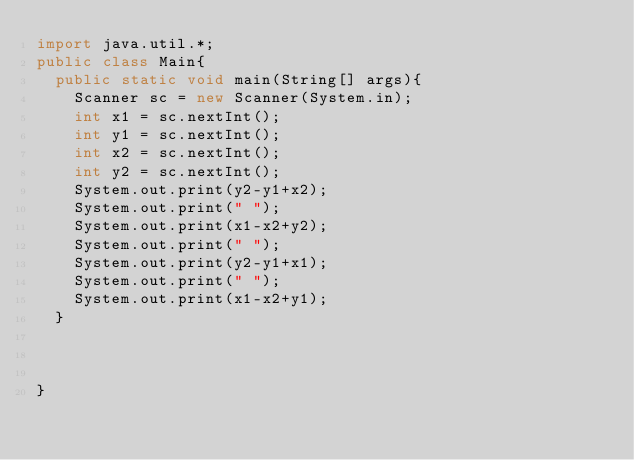Convert code to text. <code><loc_0><loc_0><loc_500><loc_500><_Java_>import java.util.*;
public class Main{
  public static void main(String[] args){
    Scanner sc = new Scanner(System.in);
    int x1 = sc.nextInt();
    int y1 = sc.nextInt();
    int x2 = sc.nextInt();
    int y2 = sc.nextInt();
    System.out.print(y2-y1+x2);
    System.out.print(" ");
    System.out.print(x1-x2+y2);
    System.out.print(" ");
    System.out.print(y2-y1+x1);
    System.out.print(" ");
    System.out.print(x1-x2+y1);
  }
  

  
}</code> 